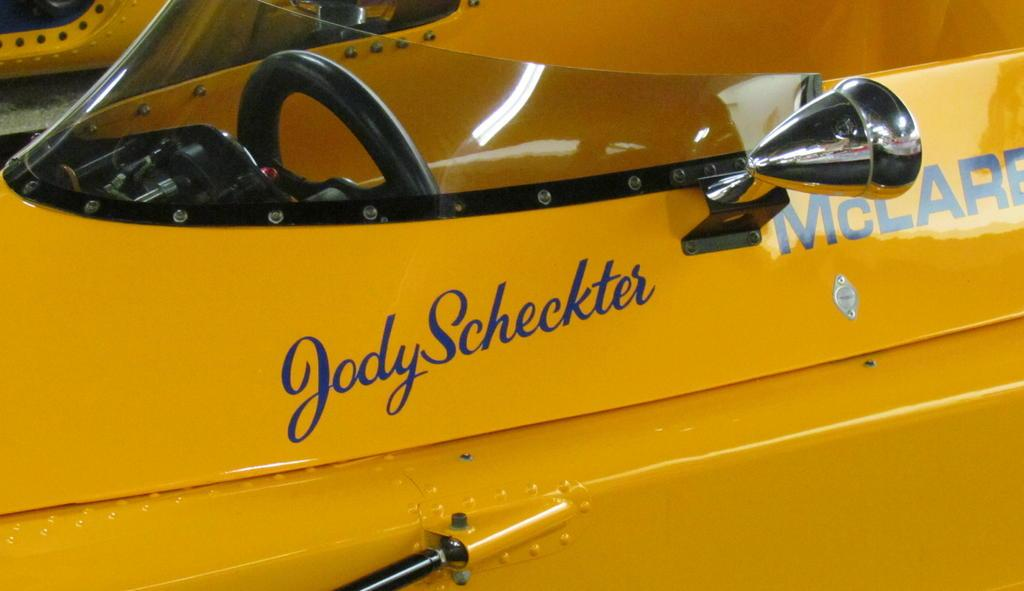What color is the vehicle in the image? The vehicle in the image is yellow. What is written or printed on the vehicle? The vehicle has text on it. How many rabbits can be seen playing with the vehicle in the image? There are no rabbits present in the image, and they are not interacting with the vehicle. 